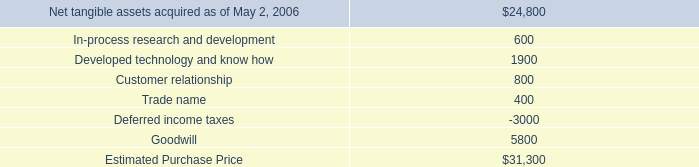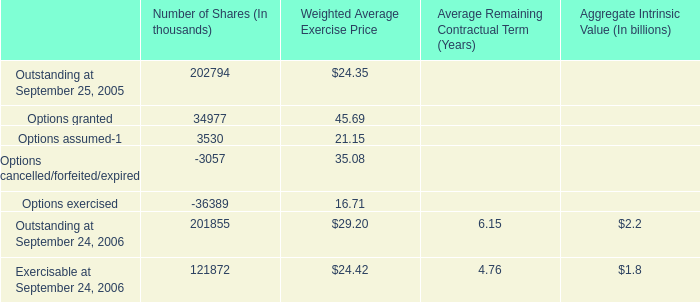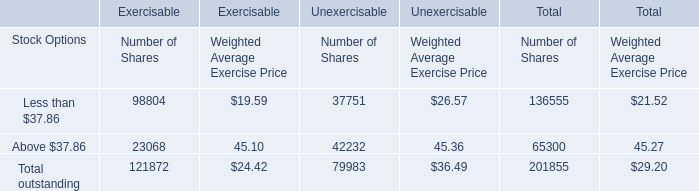What's the Number of Shares for Stock Options Less than $37.86 for Total? 
Answer: 136555. 